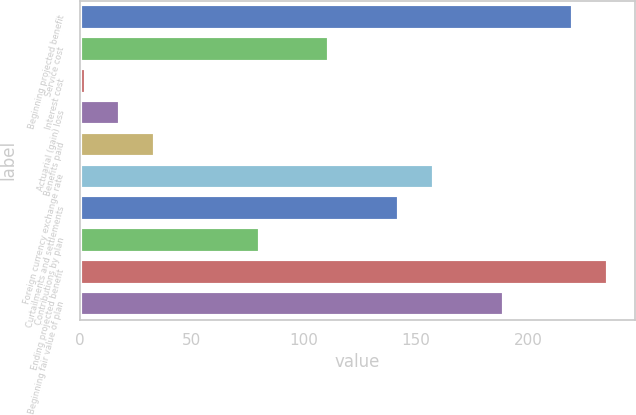Convert chart. <chart><loc_0><loc_0><loc_500><loc_500><bar_chart><fcel>Beginning projected benefit<fcel>Service cost<fcel>Interest cost<fcel>Actuarial (gain) loss<fcel>Benefits paid<fcel>Foreign currency exchange rate<fcel>Curtailments and settlements<fcel>Contributions by plan<fcel>Ending projected benefit<fcel>Beginning fair value of plan<nl><fcel>220.26<fcel>111.48<fcel>2.7<fcel>18.24<fcel>33.78<fcel>158.1<fcel>142.56<fcel>80.4<fcel>235.8<fcel>189.18<nl></chart> 